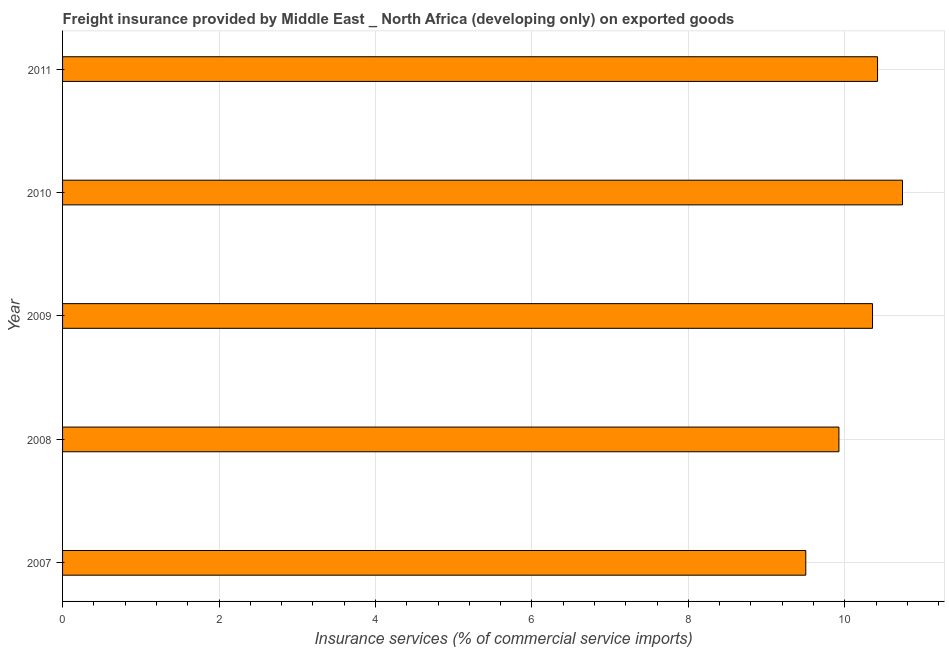What is the title of the graph?
Your answer should be very brief. Freight insurance provided by Middle East _ North Africa (developing only) on exported goods . What is the label or title of the X-axis?
Keep it short and to the point. Insurance services (% of commercial service imports). What is the label or title of the Y-axis?
Make the answer very short. Year. What is the freight insurance in 2009?
Give a very brief answer. 10.35. Across all years, what is the maximum freight insurance?
Keep it short and to the point. 10.74. Across all years, what is the minimum freight insurance?
Offer a terse response. 9.5. In which year was the freight insurance maximum?
Give a very brief answer. 2010. In which year was the freight insurance minimum?
Make the answer very short. 2007. What is the sum of the freight insurance?
Provide a succinct answer. 50.93. What is the difference between the freight insurance in 2007 and 2010?
Make the answer very short. -1.24. What is the average freight insurance per year?
Your response must be concise. 10.19. What is the median freight insurance?
Keep it short and to the point. 10.35. What is the ratio of the freight insurance in 2008 to that in 2011?
Your answer should be compact. 0.95. Is the freight insurance in 2009 less than that in 2011?
Your answer should be very brief. Yes. What is the difference between the highest and the second highest freight insurance?
Your answer should be very brief. 0.32. What is the difference between the highest and the lowest freight insurance?
Your answer should be compact. 1.24. In how many years, is the freight insurance greater than the average freight insurance taken over all years?
Your answer should be very brief. 3. Are all the bars in the graph horizontal?
Keep it short and to the point. Yes. How many years are there in the graph?
Ensure brevity in your answer.  5. What is the Insurance services (% of commercial service imports) of 2007?
Give a very brief answer. 9.5. What is the Insurance services (% of commercial service imports) in 2008?
Offer a very short reply. 9.92. What is the Insurance services (% of commercial service imports) in 2009?
Offer a terse response. 10.35. What is the Insurance services (% of commercial service imports) in 2010?
Offer a very short reply. 10.74. What is the Insurance services (% of commercial service imports) in 2011?
Give a very brief answer. 10.42. What is the difference between the Insurance services (% of commercial service imports) in 2007 and 2008?
Provide a succinct answer. -0.42. What is the difference between the Insurance services (% of commercial service imports) in 2007 and 2009?
Your response must be concise. -0.85. What is the difference between the Insurance services (% of commercial service imports) in 2007 and 2010?
Provide a short and direct response. -1.24. What is the difference between the Insurance services (% of commercial service imports) in 2007 and 2011?
Give a very brief answer. -0.92. What is the difference between the Insurance services (% of commercial service imports) in 2008 and 2009?
Your response must be concise. -0.43. What is the difference between the Insurance services (% of commercial service imports) in 2008 and 2010?
Your answer should be compact. -0.81. What is the difference between the Insurance services (% of commercial service imports) in 2008 and 2011?
Provide a succinct answer. -0.49. What is the difference between the Insurance services (% of commercial service imports) in 2009 and 2010?
Provide a short and direct response. -0.38. What is the difference between the Insurance services (% of commercial service imports) in 2009 and 2011?
Your answer should be very brief. -0.06. What is the difference between the Insurance services (% of commercial service imports) in 2010 and 2011?
Give a very brief answer. 0.32. What is the ratio of the Insurance services (% of commercial service imports) in 2007 to that in 2008?
Your answer should be very brief. 0.96. What is the ratio of the Insurance services (% of commercial service imports) in 2007 to that in 2009?
Offer a very short reply. 0.92. What is the ratio of the Insurance services (% of commercial service imports) in 2007 to that in 2010?
Your answer should be very brief. 0.89. What is the ratio of the Insurance services (% of commercial service imports) in 2007 to that in 2011?
Your response must be concise. 0.91. What is the ratio of the Insurance services (% of commercial service imports) in 2008 to that in 2010?
Your answer should be compact. 0.92. What is the ratio of the Insurance services (% of commercial service imports) in 2008 to that in 2011?
Your answer should be compact. 0.95. What is the ratio of the Insurance services (% of commercial service imports) in 2009 to that in 2011?
Provide a succinct answer. 0.99. What is the ratio of the Insurance services (% of commercial service imports) in 2010 to that in 2011?
Provide a short and direct response. 1.03. 